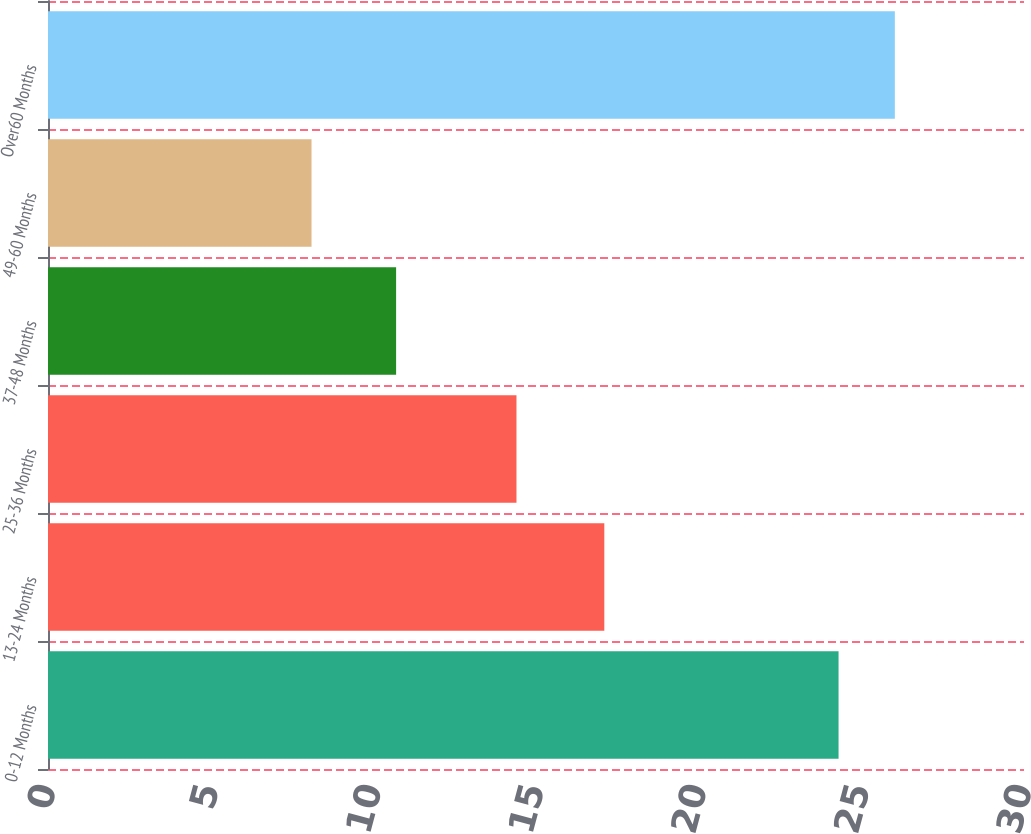<chart> <loc_0><loc_0><loc_500><loc_500><bar_chart><fcel>0-12 Months<fcel>13-24 Months<fcel>25-36 Months<fcel>37-48 Months<fcel>49-60 Months<fcel>Over60 Months<nl><fcel>24.3<fcel>17.1<fcel>14.4<fcel>10.7<fcel>8.1<fcel>26.03<nl></chart> 